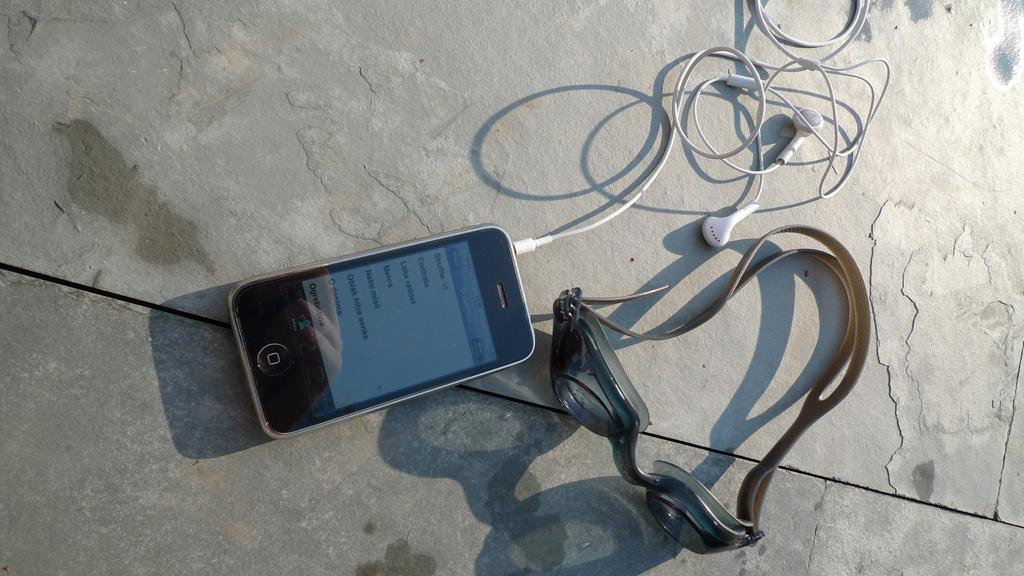<image>
Present a compact description of the photo's key features. A phone has a screen that displays the time of 17:26 at the top. 